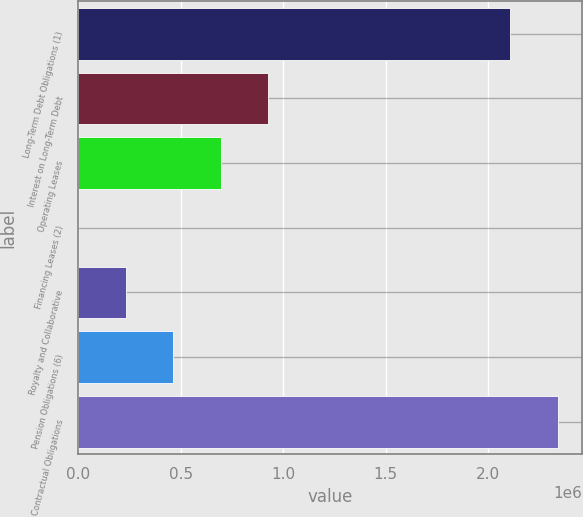Convert chart. <chart><loc_0><loc_0><loc_500><loc_500><bar_chart><fcel>Long-Term Debt Obligations (1)<fcel>Interest on Long-Term Debt<fcel>Operating Leases<fcel>Financing Leases (2)<fcel>Royalty and Collaborative<fcel>Pension Obligations (6)<fcel>Total Contractual Obligations<nl><fcel>2.11e+06<fcel>926481<fcel>694936<fcel>300<fcel>231845<fcel>463390<fcel>2.34155e+06<nl></chart> 